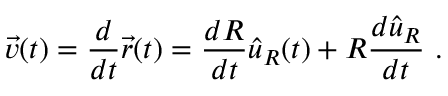<formula> <loc_0><loc_0><loc_500><loc_500>{ \vec { v } } ( t ) = { \frac { d } { d t } } { \vec { r } } ( t ) = { \frac { d R } { d t } } { \hat { u } } _ { R } ( t ) + R { \frac { d { \hat { u } } _ { R } } { d t } } \ .</formula> 